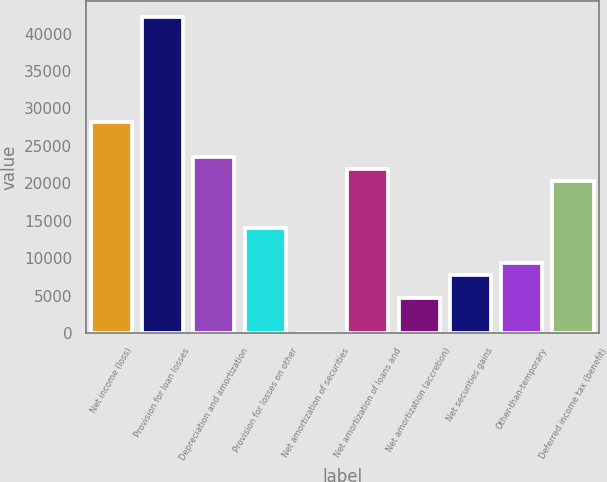Convert chart to OTSL. <chart><loc_0><loc_0><loc_500><loc_500><bar_chart><fcel>Net income (loss)<fcel>Provision for loan losses<fcel>Depreciation and amortization<fcel>Provision for losses on other<fcel>Net amortization of securities<fcel>Net amortization of loans and<fcel>Net amortization (accretion)<fcel>Net securities gains<fcel>Other-than-temporary<fcel>Deferred income tax (benefit)<nl><fcel>28154.8<fcel>42227.2<fcel>23464<fcel>14082.4<fcel>10<fcel>21900.4<fcel>4700.8<fcel>7828<fcel>9391.6<fcel>20336.8<nl></chart> 